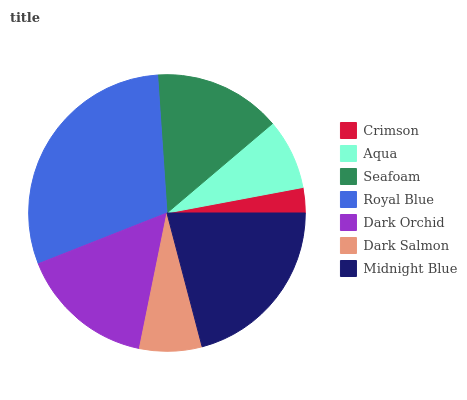Is Crimson the minimum?
Answer yes or no. Yes. Is Royal Blue the maximum?
Answer yes or no. Yes. Is Aqua the minimum?
Answer yes or no. No. Is Aqua the maximum?
Answer yes or no. No. Is Aqua greater than Crimson?
Answer yes or no. Yes. Is Crimson less than Aqua?
Answer yes or no. Yes. Is Crimson greater than Aqua?
Answer yes or no. No. Is Aqua less than Crimson?
Answer yes or no. No. Is Seafoam the high median?
Answer yes or no. Yes. Is Seafoam the low median?
Answer yes or no. Yes. Is Dark Salmon the high median?
Answer yes or no. No. Is Aqua the low median?
Answer yes or no. No. 